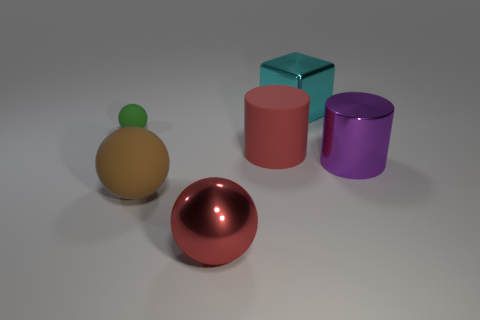Is the big shiny ball the same color as the matte cylinder?
Offer a terse response. Yes. There is a big cylinder that is left of the purple object; is its color the same as the metallic ball?
Offer a very short reply. Yes. Is there any other thing that has the same color as the big rubber cylinder?
Provide a succinct answer. Yes. Do the big cylinder that is left of the big cyan object and the large metal object that is in front of the shiny cylinder have the same color?
Provide a succinct answer. Yes. What shape is the large shiny object that is the same color as the big matte cylinder?
Provide a short and direct response. Sphere. What is the color of the block?
Give a very brief answer. Cyan. There is a large red object behind the big brown matte sphere; is its shape the same as the large metallic thing that is to the right of the cyan cube?
Your response must be concise. Yes. What is the color of the rubber ball that is to the right of the tiny green rubber thing?
Give a very brief answer. Brown. Is the number of large objects in front of the block less than the number of objects on the left side of the big metallic cylinder?
Your response must be concise. Yes. Does the green thing have the same material as the big purple cylinder?
Give a very brief answer. No. 